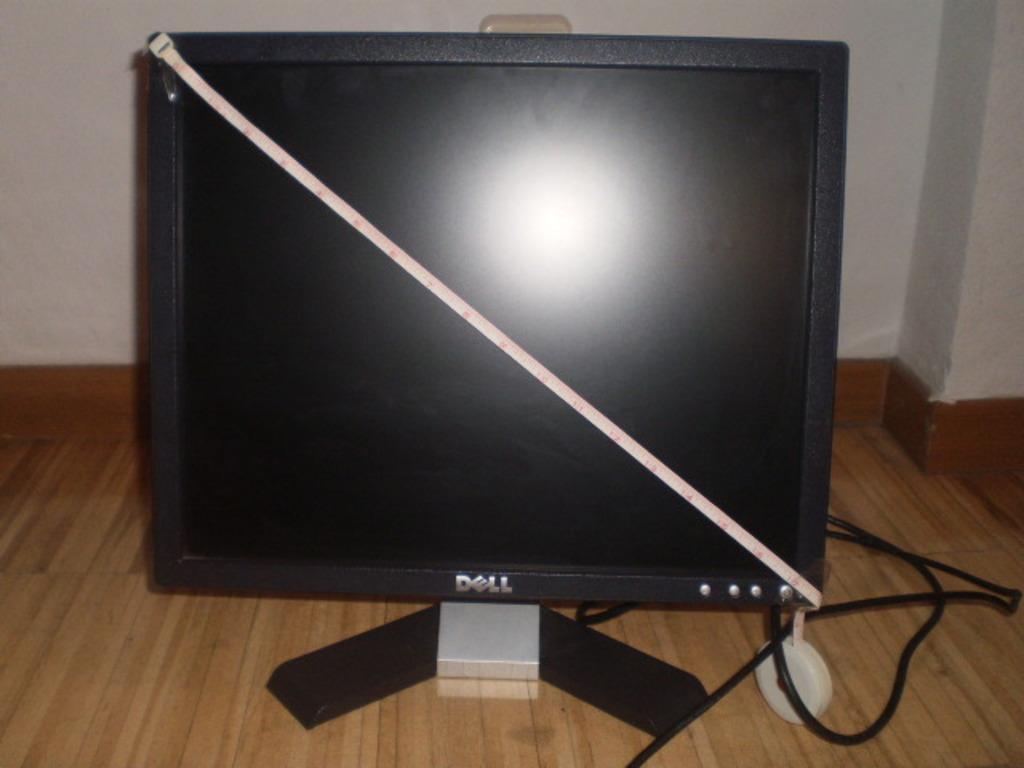What's the make of the monitor?
Your answer should be compact. Dell. 